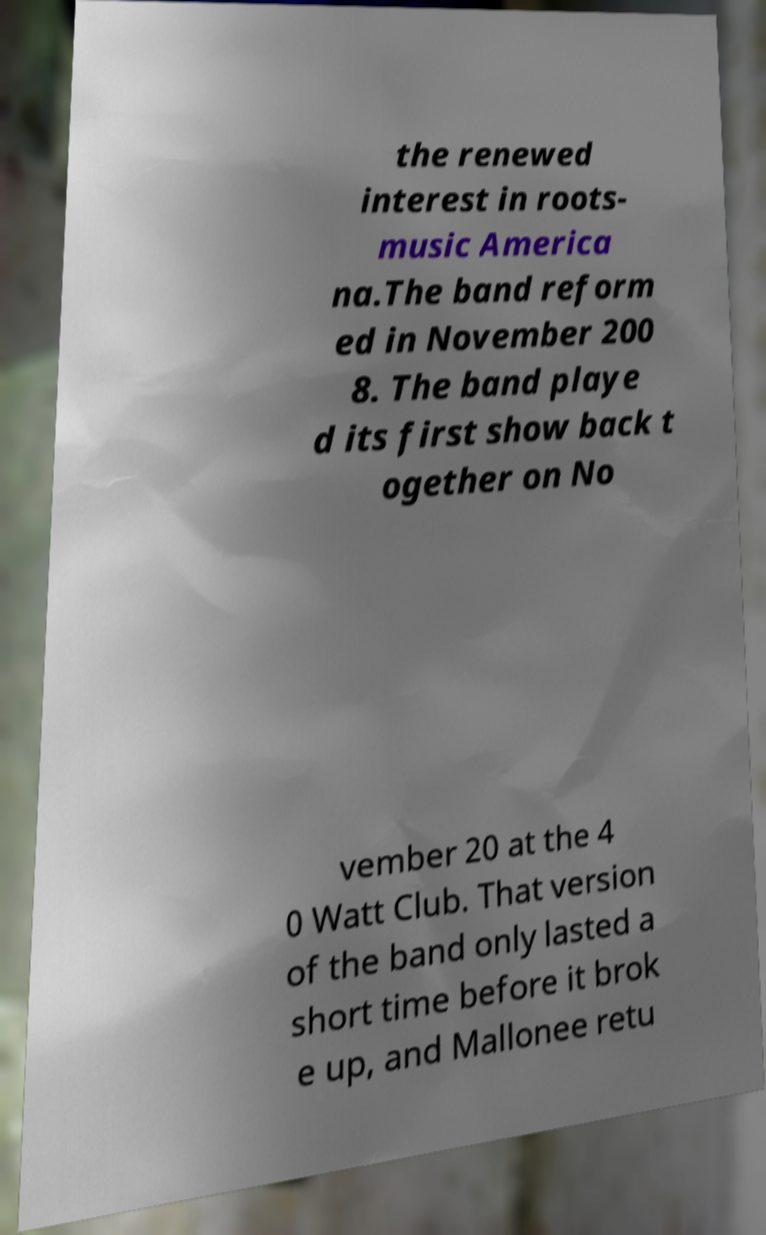Could you extract and type out the text from this image? the renewed interest in roots- music America na.The band reform ed in November 200 8. The band playe d its first show back t ogether on No vember 20 at the 4 0 Watt Club. That version of the band only lasted a short time before it brok e up, and Mallonee retu 